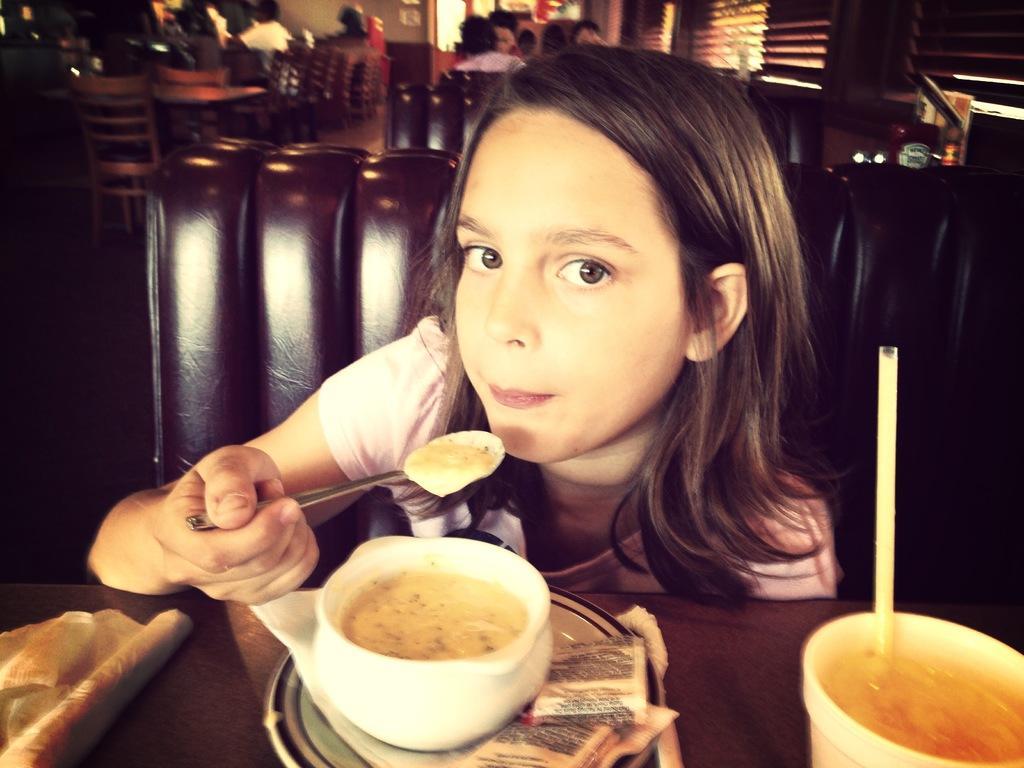How would you summarize this image in a sentence or two? In this image we can see few people. A person is eating the food. There is some food placed on the table. There are few tables and chairs in the image. There are few objects at the right side of the image. 